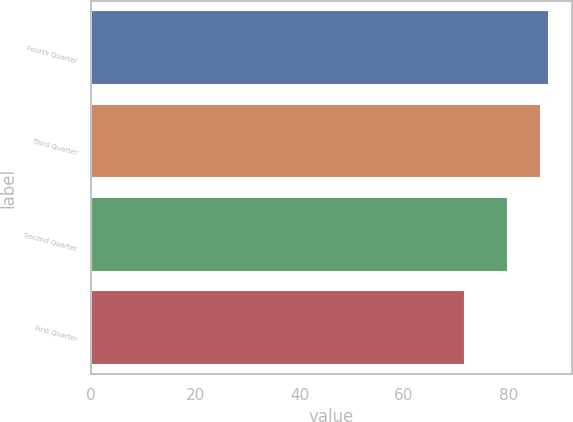Convert chart. <chart><loc_0><loc_0><loc_500><loc_500><bar_chart><fcel>Fourth Quarter<fcel>Third Quarter<fcel>Second Quarter<fcel>First Quarter<nl><fcel>87.78<fcel>86.23<fcel>79.92<fcel>71.75<nl></chart> 